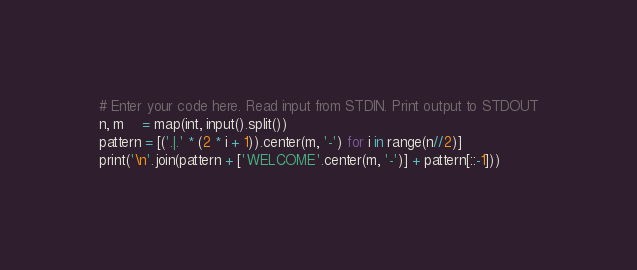<code> <loc_0><loc_0><loc_500><loc_500><_Python_># Enter your code here. Read input from STDIN. Print output to STDOUT
n, m    = map(int, input().split())
pattern = [('.|.' * (2 * i + 1)).center(m, '-') for i in range(n//2)]
print('\n'.join(pattern + ['WELCOME'.center(m, '-')] + pattern[::-1]))
</code> 